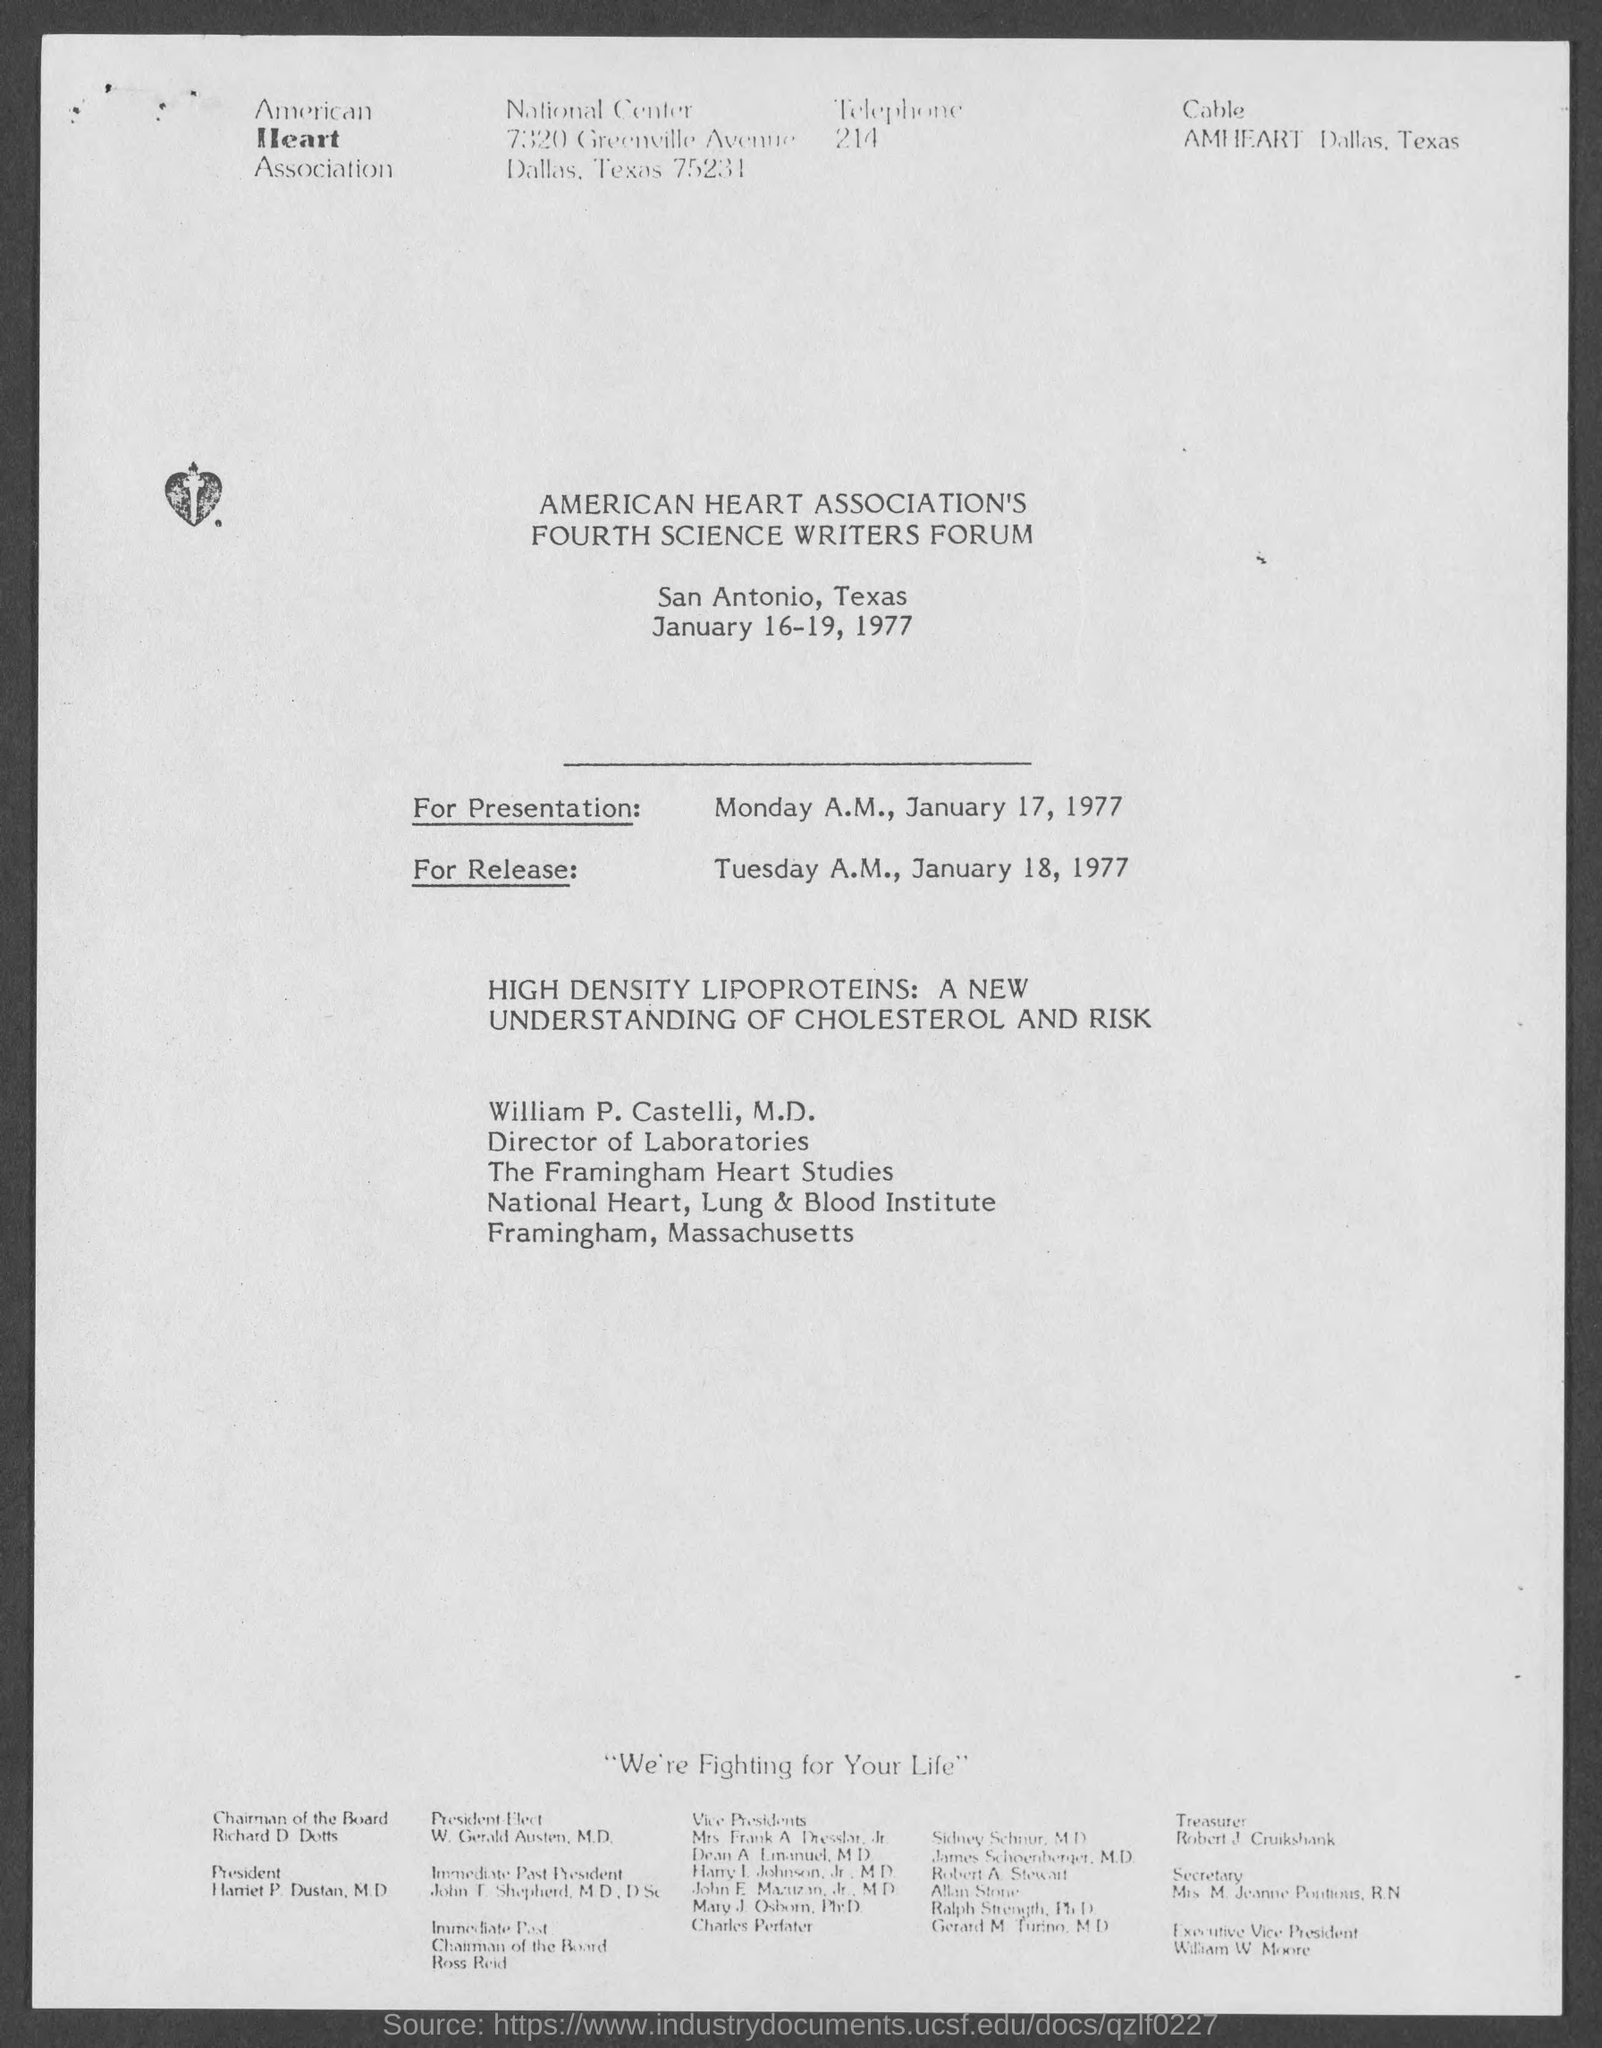Mention a couple of crucial points in this snapshot. The event is located in the state of Texas. 